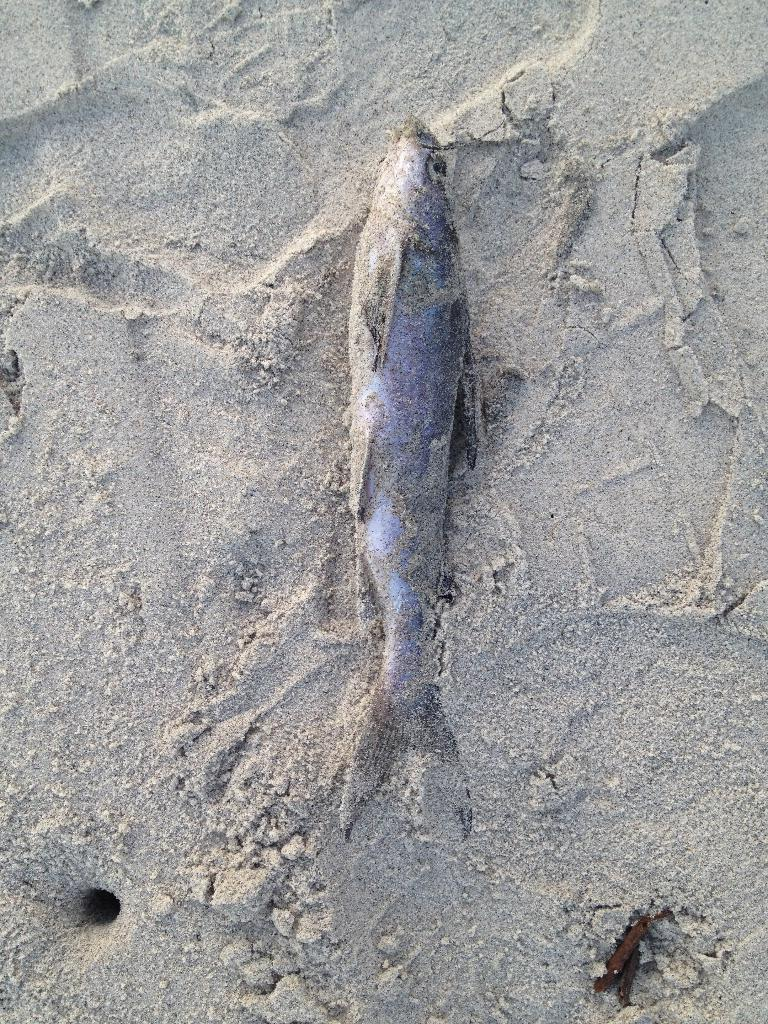What is the main subject in the center of the image? There is a fish on the sand in the center of the image. Can you describe the object located in the bottom right side of the image? There is a brown color object in the bottom right side of the image. How does the fish maintain its balance on the sand in the image? The fish does not maintain its balance in the image, as it is a still image and the fish is not moving. 